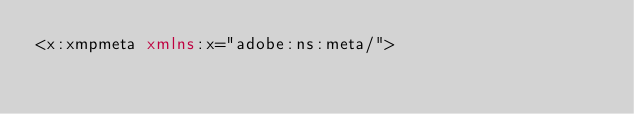<code> <loc_0><loc_0><loc_500><loc_500><_XML_><x:xmpmeta xmlns:x="adobe:ns:meta/"></code> 